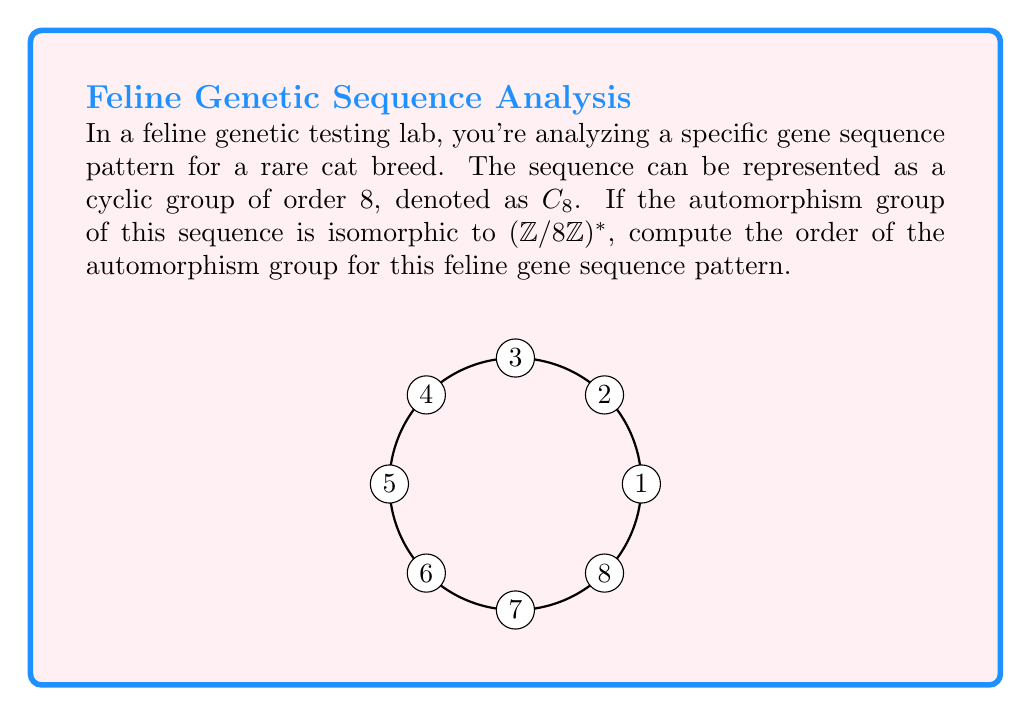Solve this math problem. Let's approach this step-by-step:

1) First, recall that for a cyclic group $C_n$, its automorphism group $\text{Aut}(C_n)$ is isomorphic to $(\mathbb{Z}/n\mathbb{Z})^*$, the group of units modulo $n$.

2) In this case, we're given that the automorphism group is isomorphic to $(\mathbb{Z}/8\mathbb{Z})^*$.

3) To find the order of $(\mathbb{Z}/8\mathbb{Z})^*$, we need to count the number of elements in $\mathbb{Z}/8\mathbb{Z}$ that are coprime to 8.

4) The elements of $\mathbb{Z}/8\mathbb{Z}$ are $\{0,1,2,3,4,5,6,7\}$.

5) The elements coprime to 8 are $\{1,3,5,7\}$.

6) Therefore, $|(\mathbb{Z}/8\mathbb{Z})^*| = 4$.

7) Since the automorphism group is isomorphic to $(\mathbb{Z}/8\mathbb{Z})^*$, it must have the same order.

Thus, the order of the automorphism group for this feline gene sequence pattern is 4.
Answer: 4 